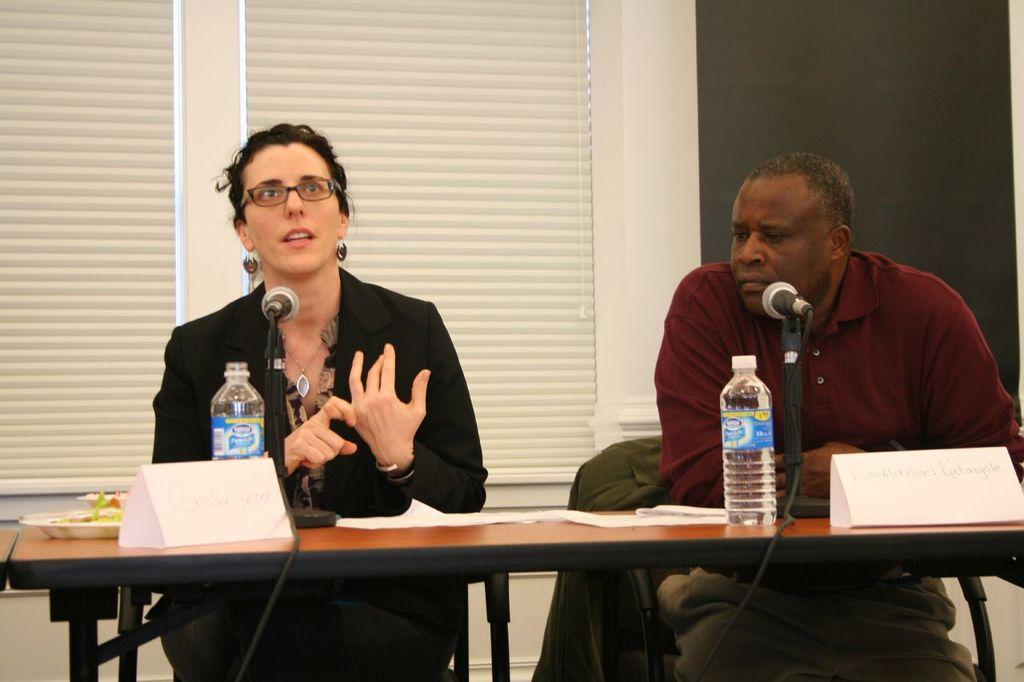Describe this image in one or two sentences. This 2 persons are sitting on a chair. This woman wore spectacles and black jacket. This man wore red t-shirt. This is window with curtain. In-front of this 2 persons there is a table. On a table there is a card, plate, bottle and a mic. 